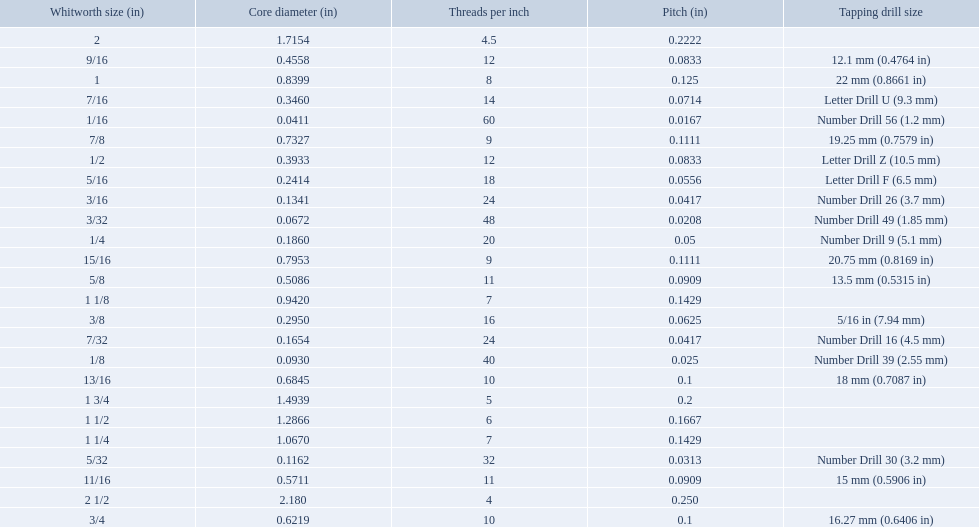What are the whitworth sizes? 1/16, 3/32, 1/8, 5/32, 3/16, 7/32, 1/4, 5/16, 3/8, 7/16, 1/2, 9/16, 5/8, 11/16, 3/4, 13/16, 7/8, 15/16, 1, 1 1/8, 1 1/4, 1 1/2, 1 3/4, 2, 2 1/2. And their threads per inch? 60, 48, 40, 32, 24, 24, 20, 18, 16, 14, 12, 12, 11, 11, 10, 10, 9, 9, 8, 7, 7, 6, 5, 4.5, 4. Now, which whitworth size has a thread-per-inch size of 5?? 1 3/4. What was the core diameter of a number drill 26 0.1341. What is this measurement in whitworth size? 3/16. 